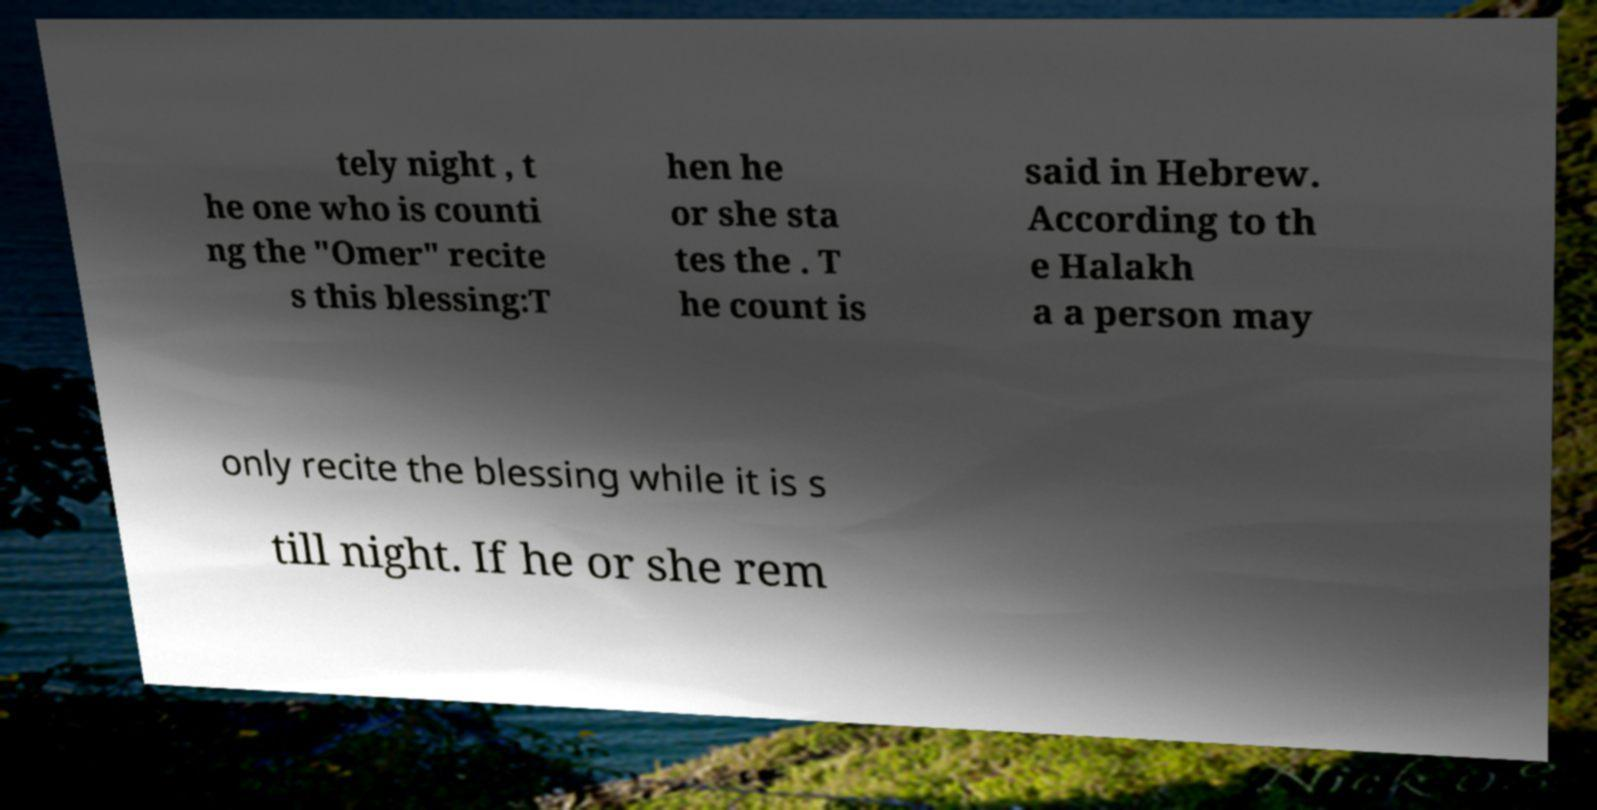Please identify and transcribe the text found in this image. tely night , t he one who is counti ng the "Omer" recite s this blessing:T hen he or she sta tes the . T he count is said in Hebrew. According to th e Halakh a a person may only recite the blessing while it is s till night. If he or she rem 